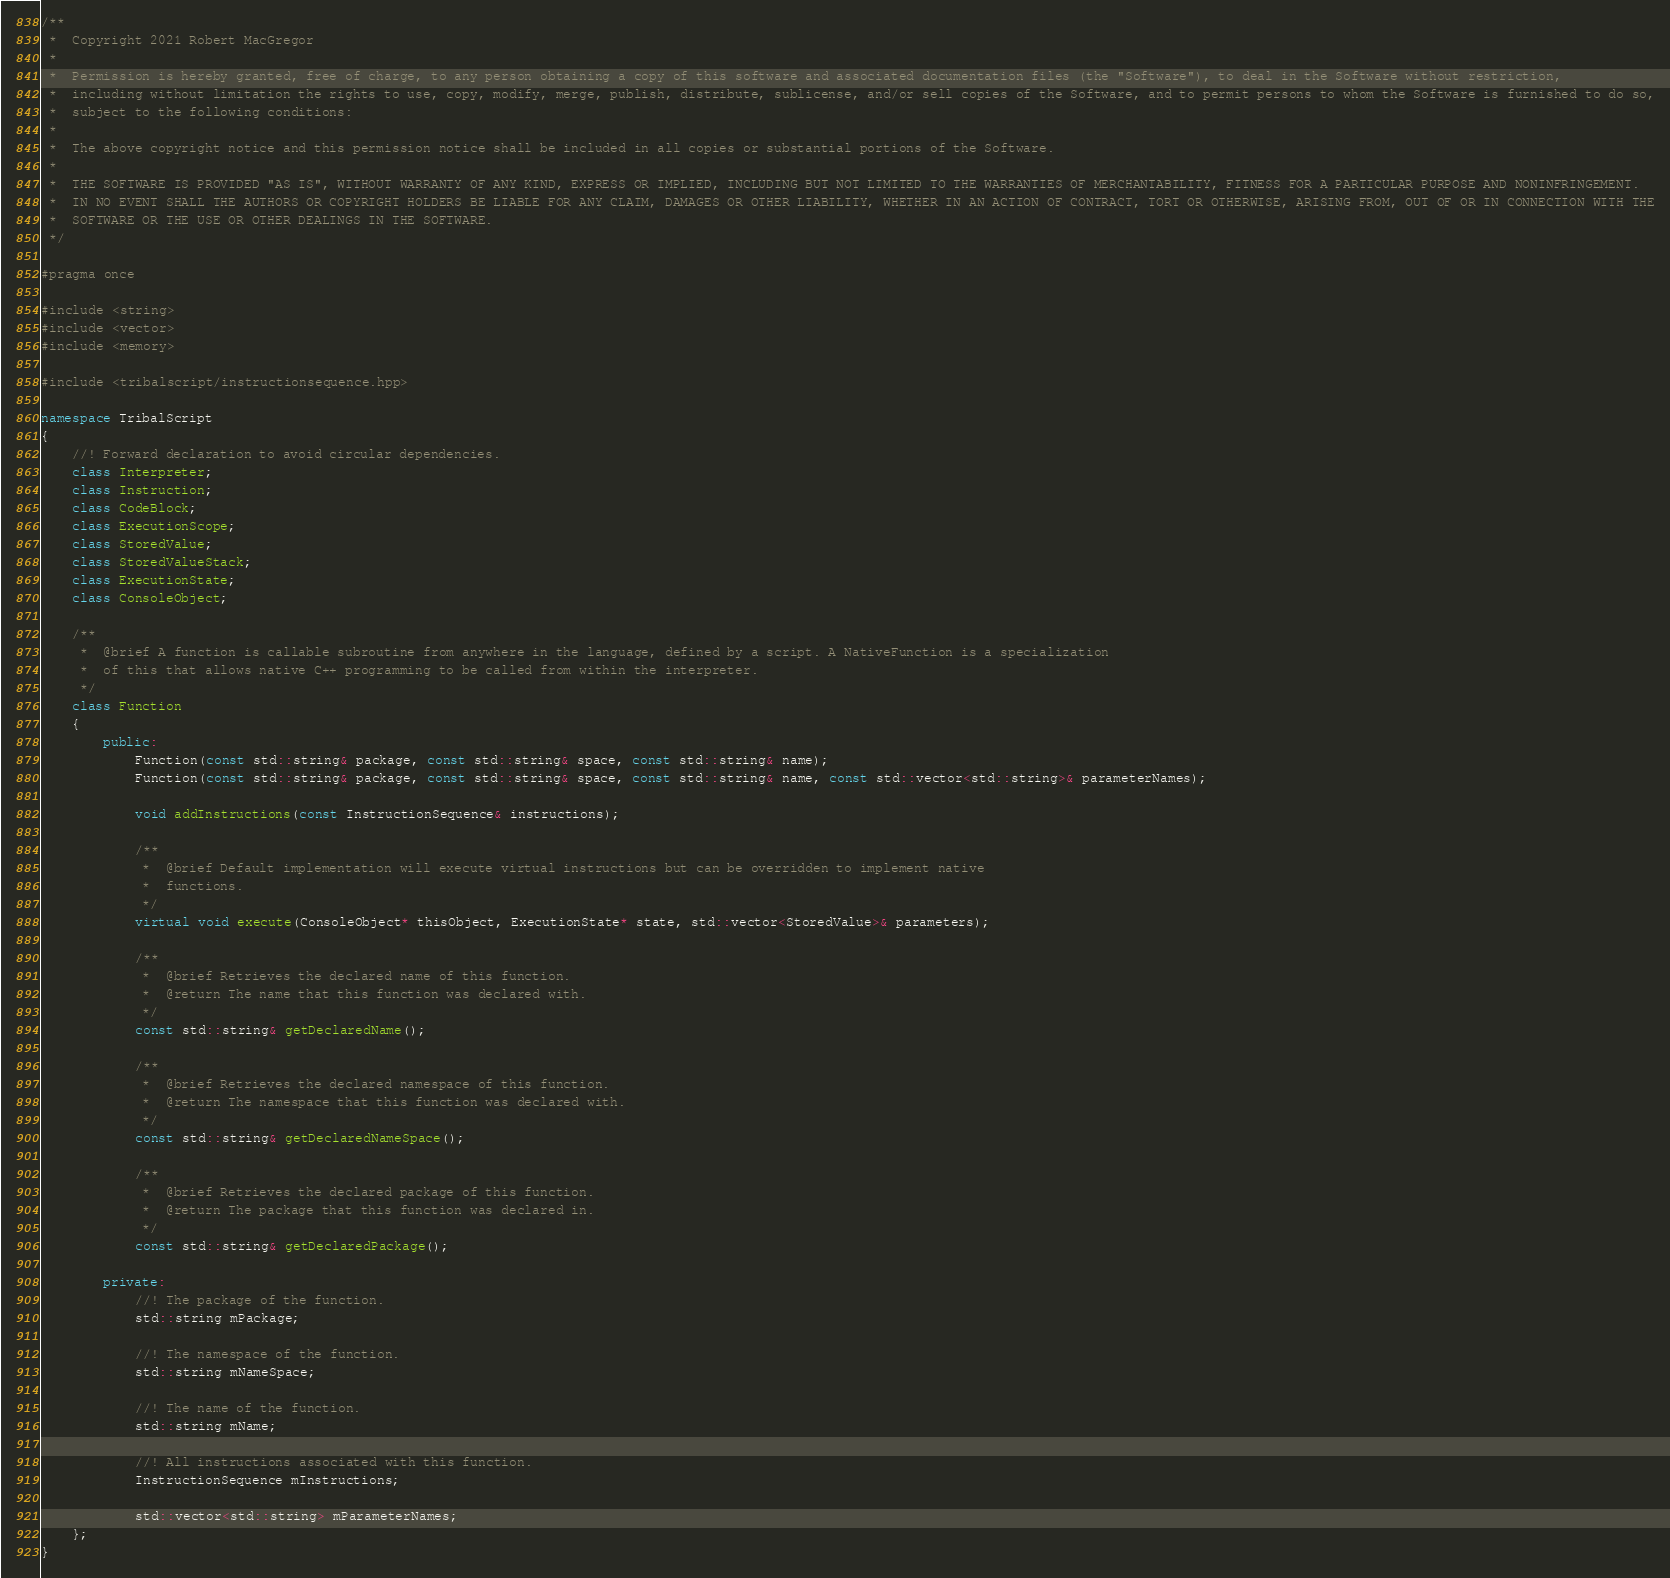<code> <loc_0><loc_0><loc_500><loc_500><_C++_>/**
 *  Copyright 2021 Robert MacGregor
 *
 *  Permission is hereby granted, free of charge, to any person obtaining a copy of this software and associated documentation files (the "Software"), to deal in the Software without restriction,
 *  including without limitation the rights to use, copy, modify, merge, publish, distribute, sublicense, and/or sell copies of the Software, and to permit persons to whom the Software is furnished to do so,
 *  subject to the following conditions:
 *
 *  The above copyright notice and this permission notice shall be included in all copies or substantial portions of the Software.
 *
 *  THE SOFTWARE IS PROVIDED "AS IS", WITHOUT WARRANTY OF ANY KIND, EXPRESS OR IMPLIED, INCLUDING BUT NOT LIMITED TO THE WARRANTIES OF MERCHANTABILITY, FITNESS FOR A PARTICULAR PURPOSE AND NONINFRINGEMENT.
 *  IN NO EVENT SHALL THE AUTHORS OR COPYRIGHT HOLDERS BE LIABLE FOR ANY CLAIM, DAMAGES OR OTHER LIABILITY, WHETHER IN AN ACTION OF CONTRACT, TORT OR OTHERWISE, ARISING FROM, OUT OF OR IN CONNECTION WITH THE
 *  SOFTWARE OR THE USE OR OTHER DEALINGS IN THE SOFTWARE.
 */

#pragma once

#include <string>
#include <vector>
#include <memory>

#include <tribalscript/instructionsequence.hpp>

namespace TribalScript
{
    //! Forward declaration to avoid circular dependencies.
    class Interpreter;
    class Instruction;
    class CodeBlock;
    class ExecutionScope;
    class StoredValue;
    class StoredValueStack;
    class ExecutionState;
    class ConsoleObject;

    /**
     *  @brief A function is callable subroutine from anywhere in the language, defined by a script. A NativeFunction is a specialization
     *  of this that allows native C++ programming to be called from within the interpreter.
     */
    class Function
    {
        public:
            Function(const std::string& package, const std::string& space, const std::string& name);
            Function(const std::string& package, const std::string& space, const std::string& name, const std::vector<std::string>& parameterNames);

            void addInstructions(const InstructionSequence& instructions);

            /**
             *  @brief Default implementation will execute virtual instructions but can be overridden to implement native
             *  functions.
             */
            virtual void execute(ConsoleObject* thisObject, ExecutionState* state, std::vector<StoredValue>& parameters);

            /**
             *  @brief Retrieves the declared name of this function.
             *  @return The name that this function was declared with.
             */
            const std::string& getDeclaredName();

            /**
             *  @brief Retrieves the declared namespace of this function.
             *  @return The namespace that this function was declared with.
             */
            const std::string& getDeclaredNameSpace();

            /**
             *  @brief Retrieves the declared package of this function.
             *  @return The package that this function was declared in.
             */
            const std::string& getDeclaredPackage();

        private:
            //! The package of the function.
            std::string mPackage;

            //! The namespace of the function.
            std::string mNameSpace;

            //! The name of the function.
            std::string mName;

            //! All instructions associated with this function.
            InstructionSequence mInstructions;

            std::vector<std::string> mParameterNames;
    };
}
</code> 